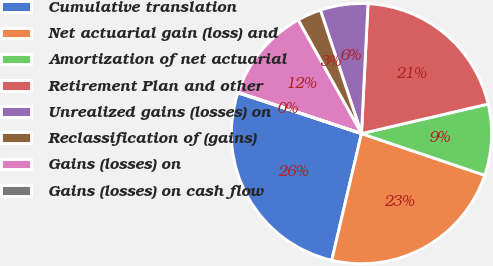Convert chart. <chart><loc_0><loc_0><loc_500><loc_500><pie_chart><fcel>Cumulative translation<fcel>Net actuarial gain (loss) and<fcel>Amortization of net actuarial<fcel>Retirement Plan and other<fcel>Unrealized gains (losses) on<fcel>Reclassification of (gains)<fcel>Gains (losses) on<fcel>Gains (losses) on cash flow<nl><fcel>26.41%<fcel>23.48%<fcel>8.84%<fcel>20.55%<fcel>5.91%<fcel>2.98%<fcel>11.77%<fcel>0.06%<nl></chart> 